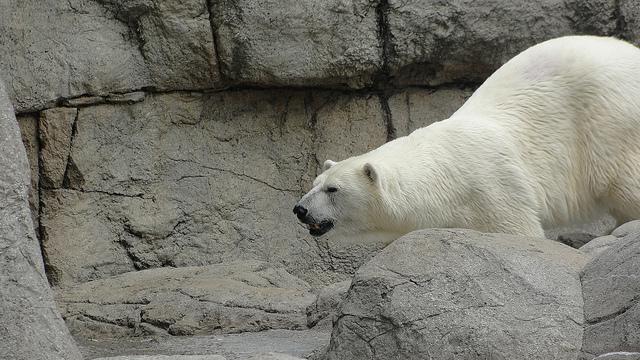What color is the bear?
Answer briefly. White. What color is this bear?
Keep it brief. White. Is the polar bear calling someone to come feed him?
Answer briefly. No. What material is the polar bear walking on?
Concise answer only. Rock. 